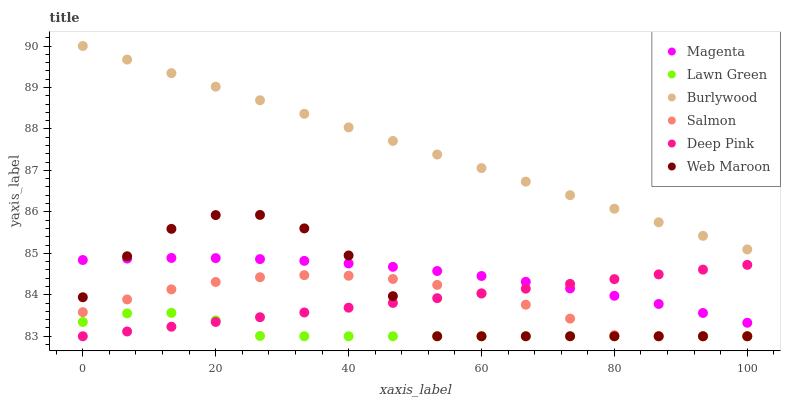Does Lawn Green have the minimum area under the curve?
Answer yes or no. Yes. Does Burlywood have the maximum area under the curve?
Answer yes or no. Yes. Does Deep Pink have the minimum area under the curve?
Answer yes or no. No. Does Deep Pink have the maximum area under the curve?
Answer yes or no. No. Is Deep Pink the smoothest?
Answer yes or no. Yes. Is Web Maroon the roughest?
Answer yes or no. Yes. Is Burlywood the smoothest?
Answer yes or no. No. Is Burlywood the roughest?
Answer yes or no. No. Does Lawn Green have the lowest value?
Answer yes or no. Yes. Does Burlywood have the lowest value?
Answer yes or no. No. Does Burlywood have the highest value?
Answer yes or no. Yes. Does Deep Pink have the highest value?
Answer yes or no. No. Is Lawn Green less than Magenta?
Answer yes or no. Yes. Is Magenta greater than Salmon?
Answer yes or no. Yes. Does Web Maroon intersect Deep Pink?
Answer yes or no. Yes. Is Web Maroon less than Deep Pink?
Answer yes or no. No. Is Web Maroon greater than Deep Pink?
Answer yes or no. No. Does Lawn Green intersect Magenta?
Answer yes or no. No. 